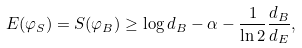Convert formula to latex. <formula><loc_0><loc_0><loc_500><loc_500>E ( \varphi _ { S } ) = S ( \varphi _ { B } ) \geq \log d _ { B } - \alpha - \frac { 1 } { \ln 2 } \frac { d _ { B } } { d _ { E } } ,</formula> 